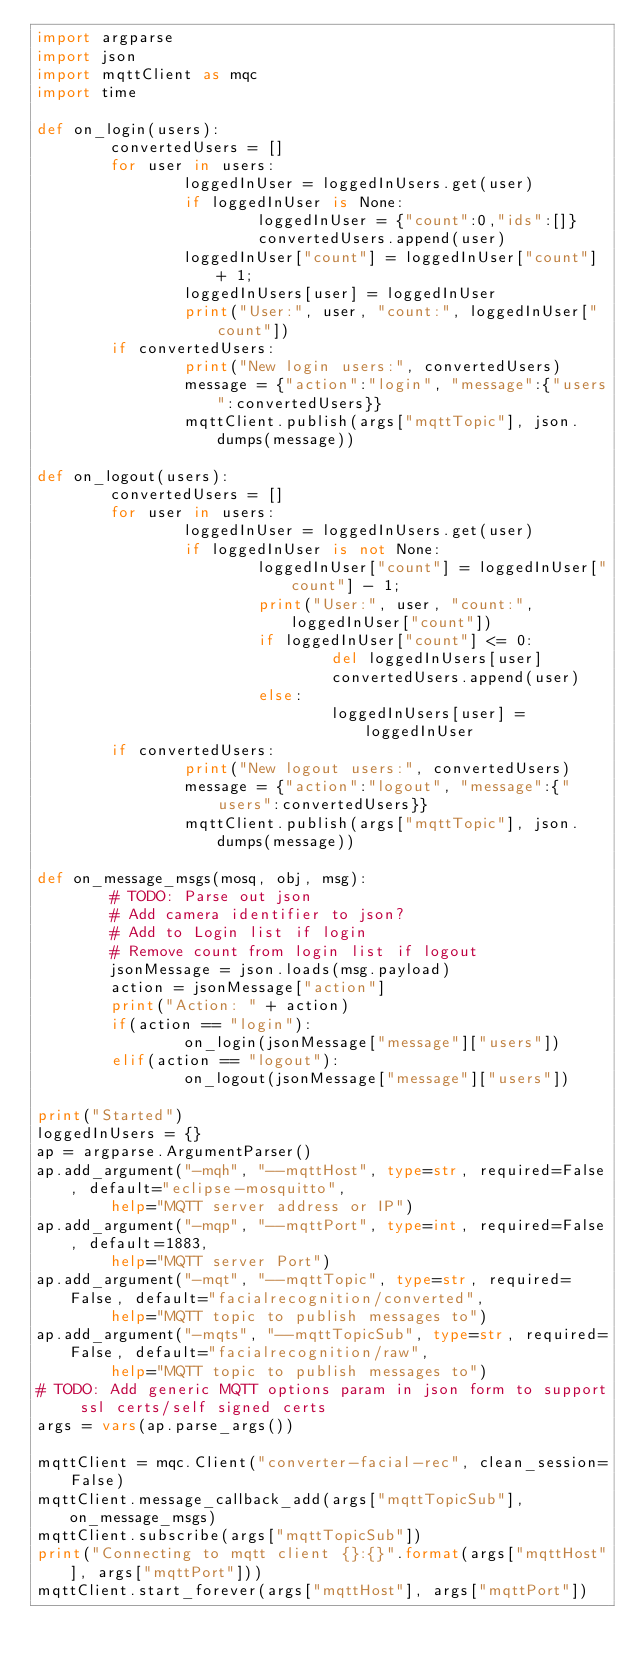<code> <loc_0><loc_0><loc_500><loc_500><_Python_>import argparse
import json
import mqttClient as mqc
import time

def on_login(users):
        convertedUsers = []
        for user in users:
                loggedInUser = loggedInUsers.get(user)
                if loggedInUser is None:
                        loggedInUser = {"count":0,"ids":[]}
                        convertedUsers.append(user)
                loggedInUser["count"] = loggedInUser["count"] + 1;
                loggedInUsers[user] = loggedInUser
                print("User:", user, "count:", loggedInUser["count"])
        if convertedUsers:
                print("New login users:", convertedUsers)
                message = {"action":"login", "message":{"users":convertedUsers}}
                mqttClient.publish(args["mqttTopic"], json.dumps(message))

def on_logout(users):
        convertedUsers = []
        for user in users:
                loggedInUser = loggedInUsers.get(user)
                if loggedInUser is not None:
                        loggedInUser["count"] = loggedInUser["count"] - 1;
                        print("User:", user, "count:", loggedInUser["count"])
                        if loggedInUser["count"] <= 0:
                                del loggedInUsers[user]
                                convertedUsers.append(user)
                        else:
                                loggedInUsers[user] = loggedInUser
        if convertedUsers:
                print("New logout users:", convertedUsers)
                message = {"action":"logout", "message":{"users":convertedUsers}}
                mqttClient.publish(args["mqttTopic"], json.dumps(message))

def on_message_msgs(mosq, obj, msg):
        # TODO: Parse out json
        # Add camera identifier to json?
        # Add to Login list if login
        # Remove count from login list if logout
        jsonMessage = json.loads(msg.payload)
        action = jsonMessage["action"]
        print("Action: " + action)
        if(action == "login"):
                on_login(jsonMessage["message"]["users"])
        elif(action == "logout"):
                on_logout(jsonMessage["message"]["users"])

print("Started")
loggedInUsers = {}
ap = argparse.ArgumentParser()
ap.add_argument("-mqh", "--mqttHost", type=str, required=False, default="eclipse-mosquitto",
        help="MQTT server address or IP")
ap.add_argument("-mqp", "--mqttPort", type=int, required=False, default=1883,
        help="MQTT server Port")
ap.add_argument("-mqt", "--mqttTopic", type=str, required=False, default="facialrecognition/converted",
        help="MQTT topic to publish messages to")
ap.add_argument("-mqts", "--mqttTopicSub", type=str, required=False, default="facialrecognition/raw",
        help="MQTT topic to publish messages to")
# TODO: Add generic MQTT options param in json form to support ssl certs/self signed certs
args = vars(ap.parse_args())

mqttClient = mqc.Client("converter-facial-rec", clean_session=False)
mqttClient.message_callback_add(args["mqttTopicSub"], on_message_msgs)
mqttClient.subscribe(args["mqttTopicSub"])
print("Connecting to mqtt client {}:{}".format(args["mqttHost"], args["mqttPort"]))
mqttClient.start_forever(args["mqttHost"], args["mqttPort"])</code> 